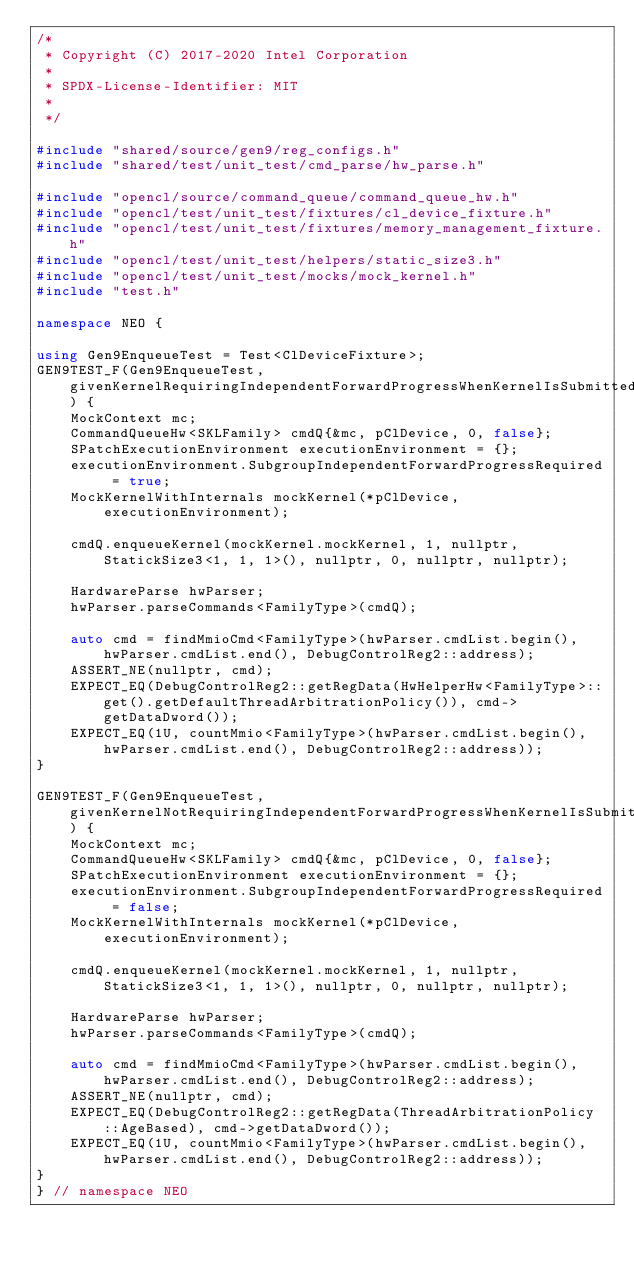Convert code to text. <code><loc_0><loc_0><loc_500><loc_500><_C++_>/*
 * Copyright (C) 2017-2020 Intel Corporation
 *
 * SPDX-License-Identifier: MIT
 *
 */

#include "shared/source/gen9/reg_configs.h"
#include "shared/test/unit_test/cmd_parse/hw_parse.h"

#include "opencl/source/command_queue/command_queue_hw.h"
#include "opencl/test/unit_test/fixtures/cl_device_fixture.h"
#include "opencl/test/unit_test/fixtures/memory_management_fixture.h"
#include "opencl/test/unit_test/helpers/static_size3.h"
#include "opencl/test/unit_test/mocks/mock_kernel.h"
#include "test.h"

namespace NEO {

using Gen9EnqueueTest = Test<ClDeviceFixture>;
GEN9TEST_F(Gen9EnqueueTest, givenKernelRequiringIndependentForwardProgressWhenKernelIsSubmittedThenRoundRobinPolicyIsProgrammed) {
    MockContext mc;
    CommandQueueHw<SKLFamily> cmdQ{&mc, pClDevice, 0, false};
    SPatchExecutionEnvironment executionEnvironment = {};
    executionEnvironment.SubgroupIndependentForwardProgressRequired = true;
    MockKernelWithInternals mockKernel(*pClDevice, executionEnvironment);

    cmdQ.enqueueKernel(mockKernel.mockKernel, 1, nullptr, StatickSize3<1, 1, 1>(), nullptr, 0, nullptr, nullptr);

    HardwareParse hwParser;
    hwParser.parseCommands<FamilyType>(cmdQ);

    auto cmd = findMmioCmd<FamilyType>(hwParser.cmdList.begin(), hwParser.cmdList.end(), DebugControlReg2::address);
    ASSERT_NE(nullptr, cmd);
    EXPECT_EQ(DebugControlReg2::getRegData(HwHelperHw<FamilyType>::get().getDefaultThreadArbitrationPolicy()), cmd->getDataDword());
    EXPECT_EQ(1U, countMmio<FamilyType>(hwParser.cmdList.begin(), hwParser.cmdList.end(), DebugControlReg2::address));
}

GEN9TEST_F(Gen9EnqueueTest, givenKernelNotRequiringIndependentForwardProgressWhenKernelIsSubmittedThenAgeBasedPolicyIsProgrammed) {
    MockContext mc;
    CommandQueueHw<SKLFamily> cmdQ{&mc, pClDevice, 0, false};
    SPatchExecutionEnvironment executionEnvironment = {};
    executionEnvironment.SubgroupIndependentForwardProgressRequired = false;
    MockKernelWithInternals mockKernel(*pClDevice, executionEnvironment);

    cmdQ.enqueueKernel(mockKernel.mockKernel, 1, nullptr, StatickSize3<1, 1, 1>(), nullptr, 0, nullptr, nullptr);

    HardwareParse hwParser;
    hwParser.parseCommands<FamilyType>(cmdQ);

    auto cmd = findMmioCmd<FamilyType>(hwParser.cmdList.begin(), hwParser.cmdList.end(), DebugControlReg2::address);
    ASSERT_NE(nullptr, cmd);
    EXPECT_EQ(DebugControlReg2::getRegData(ThreadArbitrationPolicy::AgeBased), cmd->getDataDword());
    EXPECT_EQ(1U, countMmio<FamilyType>(hwParser.cmdList.begin(), hwParser.cmdList.end(), DebugControlReg2::address));
}
} // namespace NEO
</code> 